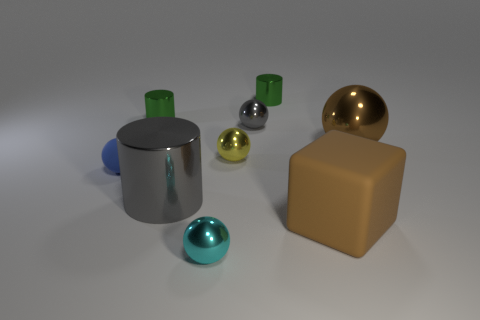Subtract all small metal spheres. How many spheres are left? 2 Subtract all red balls. How many green cylinders are left? 2 Add 1 green rubber blocks. How many objects exist? 10 Subtract all cubes. How many objects are left? 8 Subtract all gray cylinders. How many cylinders are left? 2 Subtract all blue cylinders. Subtract all green balls. How many cylinders are left? 3 Subtract all small blue objects. Subtract all blue rubber cylinders. How many objects are left? 8 Add 5 blue things. How many blue things are left? 6 Add 7 rubber balls. How many rubber balls exist? 8 Subtract 0 blue blocks. How many objects are left? 9 